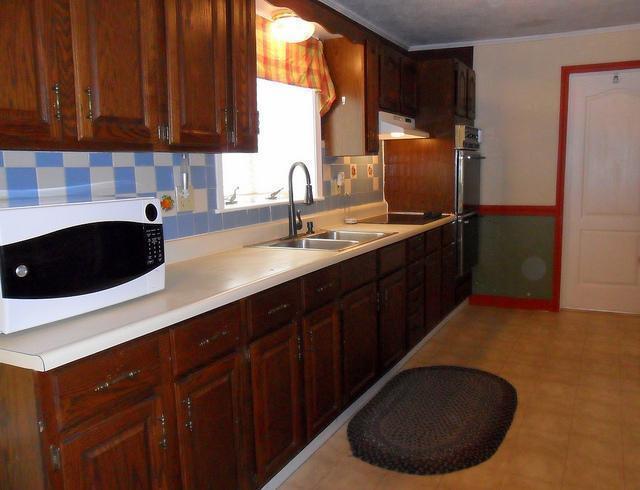What is the name for the pattern used on the window curtains?
Indicate the correct response by choosing from the four available options to answer the question.
Options: Floral, plaid, birdseye, polka dot. Plaid. 